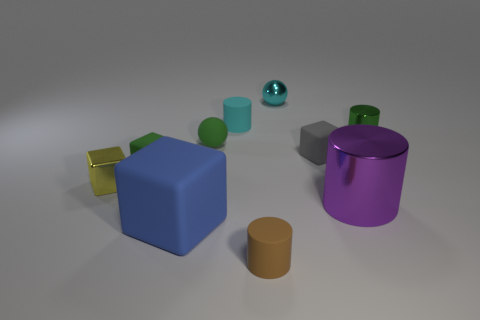Subtract all blue cubes. How many cubes are left? 3 Subtract all green balls. How many balls are left? 1 Subtract 3 cylinders. How many cylinders are left? 1 Subtract all cylinders. How many objects are left? 6 Add 8 cyan balls. How many cyan balls are left? 9 Add 4 small brown matte cylinders. How many small brown matte cylinders exist? 5 Subtract 1 cyan cylinders. How many objects are left? 9 Subtract all green cubes. Subtract all red balls. How many cubes are left? 3 Subtract all brown spheres. How many gray cubes are left? 1 Subtract all small green rubber balls. Subtract all metal objects. How many objects are left? 5 